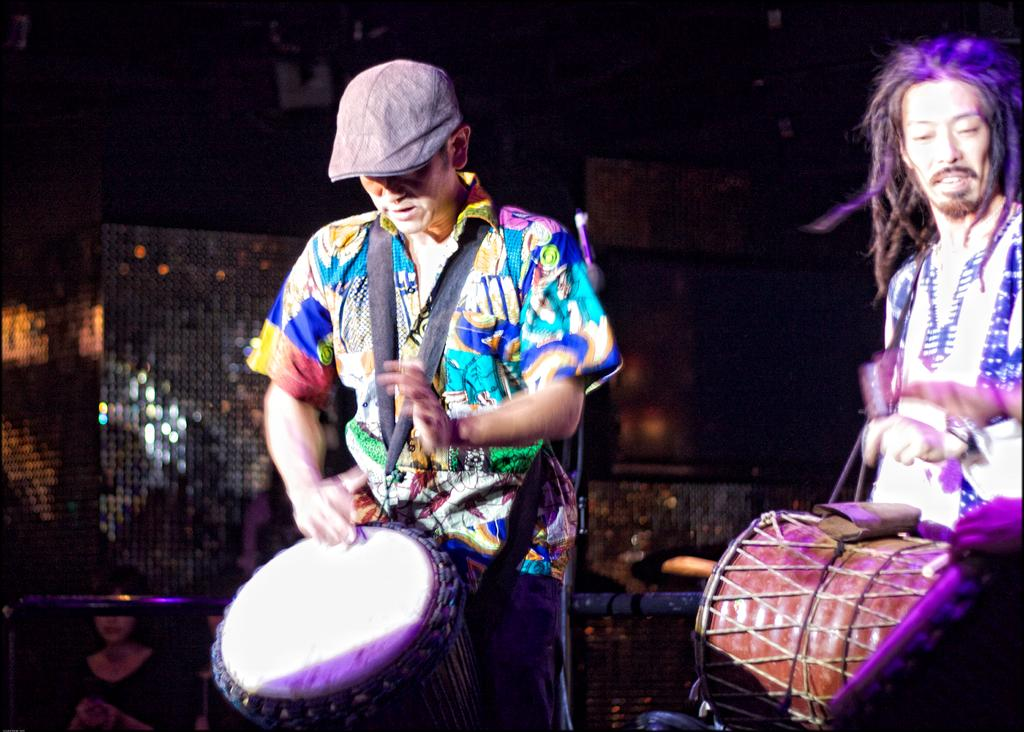How many people are in the image? There are two men in the image. What are the men holding in the image? The men are holding drums. What type of clouds can be seen in the image? There are no clouds visible in the image, as it only features two men holding drums. 